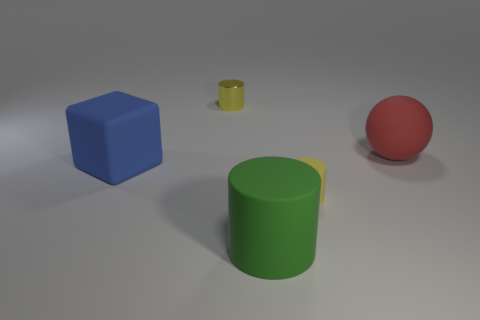What number of other objects are there of the same color as the tiny matte object?
Offer a very short reply. 1. Are there any other red objects that have the same material as the big red thing?
Provide a short and direct response. No. Do the blue cube and the large red thing have the same material?
Your answer should be very brief. Yes. What number of yellow objects are tiny shiny objects or metallic balls?
Offer a terse response. 1. Is the number of rubber objects to the right of the green object greater than the number of tiny red spheres?
Provide a short and direct response. Yes. Is there another sphere that has the same color as the rubber ball?
Offer a very short reply. No. The yellow metallic thing has what size?
Ensure brevity in your answer.  Small. Do the metal thing and the large sphere have the same color?
Your answer should be compact. No. How many objects are either matte things or big things to the left of the large cylinder?
Your response must be concise. 4. There is a yellow cylinder to the left of the tiny cylinder that is in front of the yellow metal object; what number of blocks are behind it?
Provide a succinct answer. 0. 